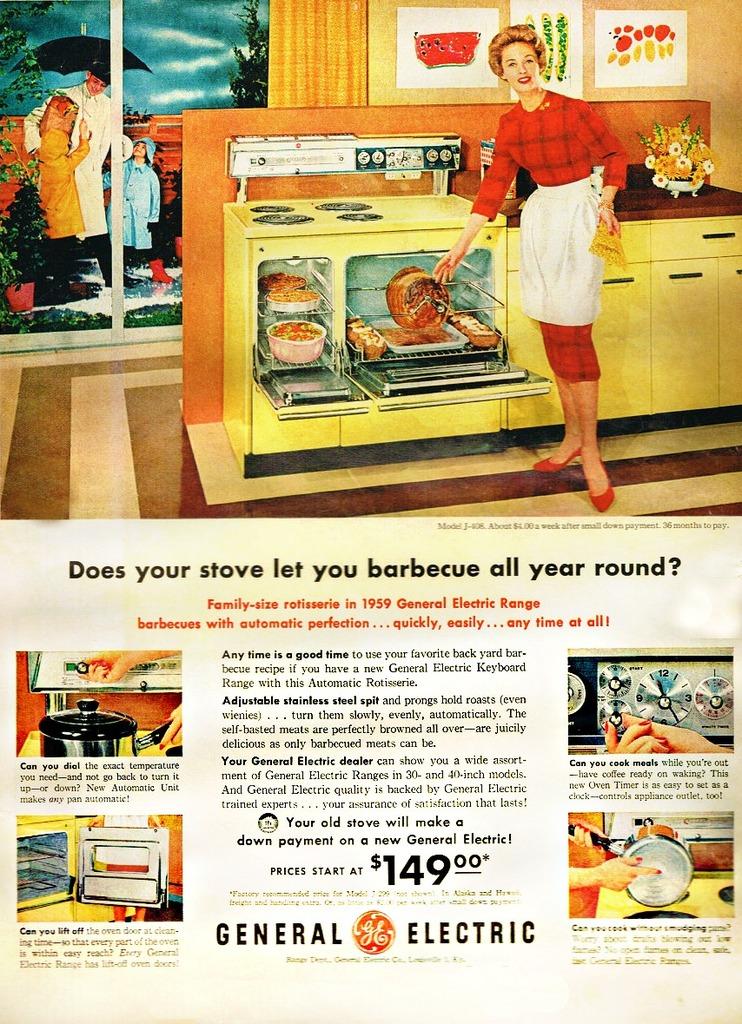What does the price start at?
Offer a terse response. 149. What product is being advertised in the ad?
Offer a terse response. Stove. 